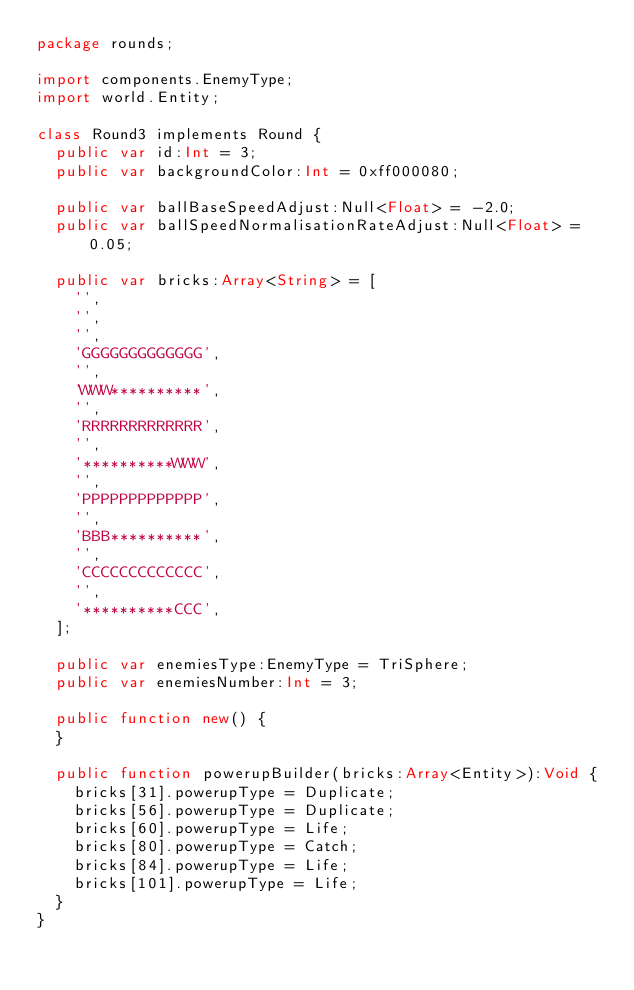Convert code to text. <code><loc_0><loc_0><loc_500><loc_500><_Haxe_>package rounds;

import components.EnemyType;
import world.Entity;

class Round3 implements Round {
  public var id:Int = 3;
  public var backgroundColor:Int = 0xff000080;

  public var ballBaseSpeedAdjust:Null<Float> = -2.0;
  public var ballSpeedNormalisationRateAdjust:Null<Float> = 0.05;

  public var bricks:Array<String> = [
    '',
    '',
    '',
    'GGGGGGGGGGGGG',
    '',
    'WWW**********',
    '',
    'RRRRRRRRRRRRR',
    '',
    '**********WWW',
    '',
    'PPPPPPPPPPPPP',
    '',
    'BBB**********',
    '',
    'CCCCCCCCCCCCC',
    '',
    '**********CCC',
  ];

  public var enemiesType:EnemyType = TriSphere;
  public var enemiesNumber:Int = 3;

  public function new() {
  }

  public function powerupBuilder(bricks:Array<Entity>):Void {
    bricks[31].powerupType = Duplicate;
    bricks[56].powerupType = Duplicate;
    bricks[60].powerupType = Life;
    bricks[80].powerupType = Catch;
    bricks[84].powerupType = Life;
    bricks[101].powerupType = Life;
  }
}
</code> 